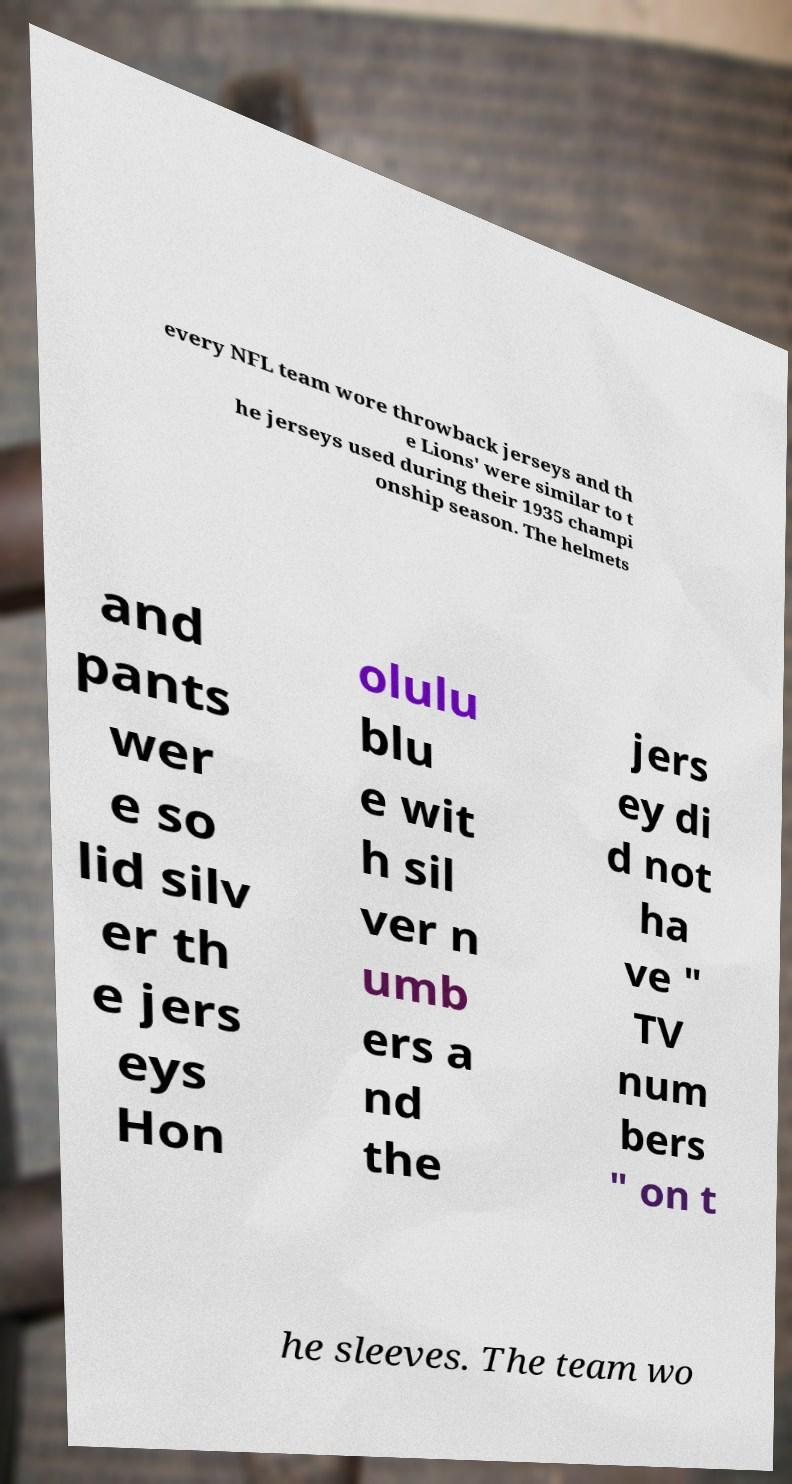Could you assist in decoding the text presented in this image and type it out clearly? every NFL team wore throwback jerseys and th e Lions' were similar to t he jerseys used during their 1935 champi onship season. The helmets and pants wer e so lid silv er th e jers eys Hon olulu blu e wit h sil ver n umb ers a nd the jers ey di d not ha ve " TV num bers " on t he sleeves. The team wo 